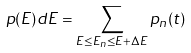Convert formula to latex. <formula><loc_0><loc_0><loc_500><loc_500>p ( E ) d E = \sum _ { E \leq E _ { n } \leq E + \Delta E } p _ { n } ( t )</formula> 